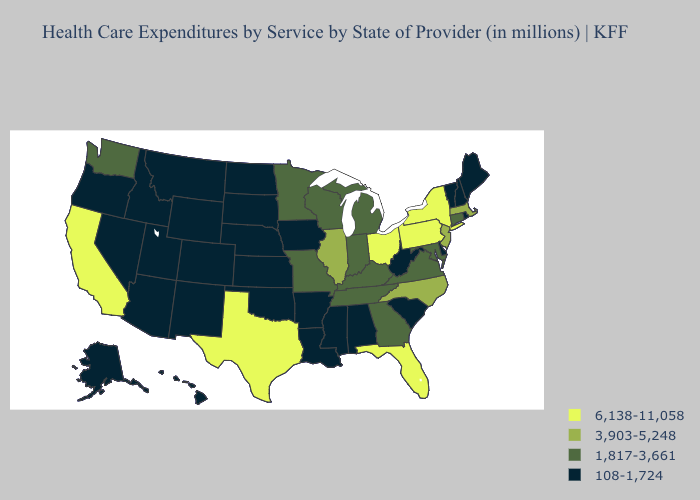Name the states that have a value in the range 6,138-11,058?
Be succinct. California, Florida, New York, Ohio, Pennsylvania, Texas. Which states hav the highest value in the Northeast?
Be succinct. New York, Pennsylvania. Name the states that have a value in the range 3,903-5,248?
Short answer required. Illinois, Massachusetts, New Jersey, North Carolina. Does Indiana have the highest value in the MidWest?
Keep it brief. No. What is the value of Arkansas?
Write a very short answer. 108-1,724. Which states have the highest value in the USA?
Write a very short answer. California, Florida, New York, Ohio, Pennsylvania, Texas. Name the states that have a value in the range 3,903-5,248?
Quick response, please. Illinois, Massachusetts, New Jersey, North Carolina. What is the lowest value in states that border Oklahoma?
Answer briefly. 108-1,724. Name the states that have a value in the range 1,817-3,661?
Quick response, please. Connecticut, Georgia, Indiana, Kentucky, Maryland, Michigan, Minnesota, Missouri, Tennessee, Virginia, Washington, Wisconsin. Does California have the highest value in the West?
Write a very short answer. Yes. What is the lowest value in the USA?
Concise answer only. 108-1,724. Among the states that border Utah , which have the lowest value?
Write a very short answer. Arizona, Colorado, Idaho, Nevada, New Mexico, Wyoming. Which states hav the highest value in the South?
Be succinct. Florida, Texas. What is the value of North Dakota?
Concise answer only. 108-1,724. Name the states that have a value in the range 108-1,724?
Be succinct. Alabama, Alaska, Arizona, Arkansas, Colorado, Delaware, Hawaii, Idaho, Iowa, Kansas, Louisiana, Maine, Mississippi, Montana, Nebraska, Nevada, New Hampshire, New Mexico, North Dakota, Oklahoma, Oregon, Rhode Island, South Carolina, South Dakota, Utah, Vermont, West Virginia, Wyoming. 